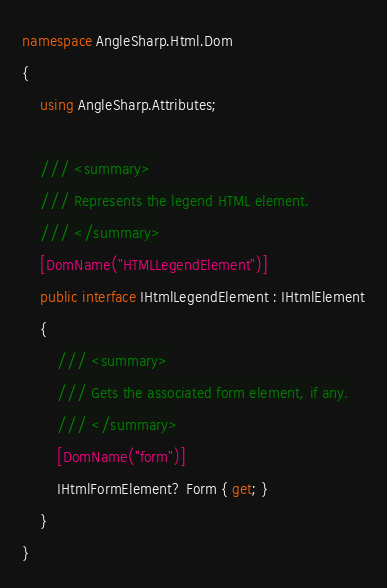<code> <loc_0><loc_0><loc_500><loc_500><_C#_>namespace AngleSharp.Html.Dom
{
    using AngleSharp.Attributes;

    /// <summary>
    /// Represents the legend HTML element.
    /// </summary>
    [DomName("HTMLLegendElement")]
    public interface IHtmlLegendElement : IHtmlElement
    {
        /// <summary>
        /// Gets the associated form element, if any.
        /// </summary>
        [DomName("form")]
        IHtmlFormElement? Form { get; }
    }
}
</code> 